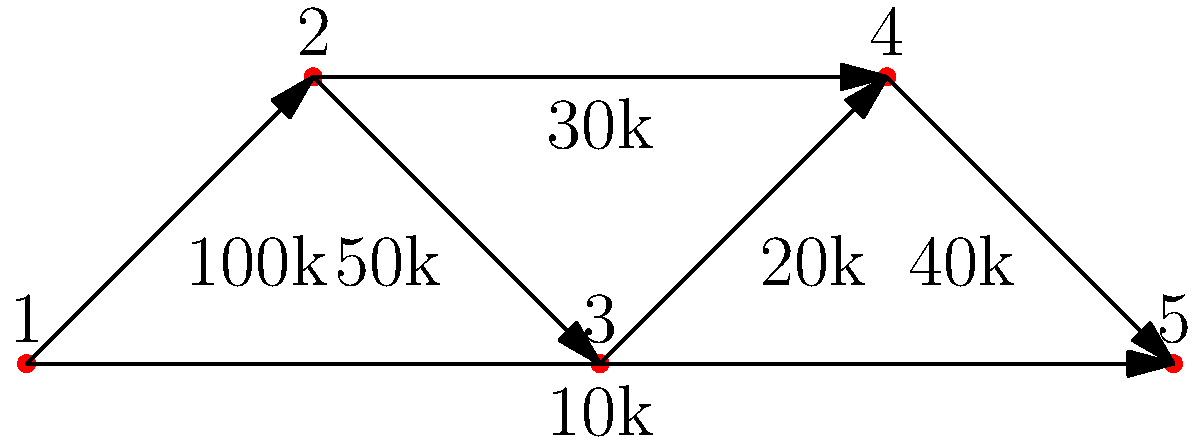In the directed graph representing financial transactions between entities, what is the total amount of money that flows through Entity 4 (including both incoming and outgoing transactions)? To determine the total amount of money flowing through Entity 4, we need to analyze both incoming and outgoing transactions:

1. Incoming transactions to Entity 4:
   - From Entity 3: $40,000
   - From Entity 1: $10,000 (direct transaction)

2. Outgoing transactions from Entity 4:
   - There are no outgoing transactions from Entity 4

3. Calculate the total flow:
   - Total incoming: $40,000 + $10,000 = $50,000
   - Total outgoing: $0

4. Sum up the total flow:
   - Total flow = Total incoming + Total outgoing
   - Total flow = $50,000 + $0 = $50,000

Therefore, the total amount of money flowing through Entity 4 is $50,000.
Answer: $50,000 